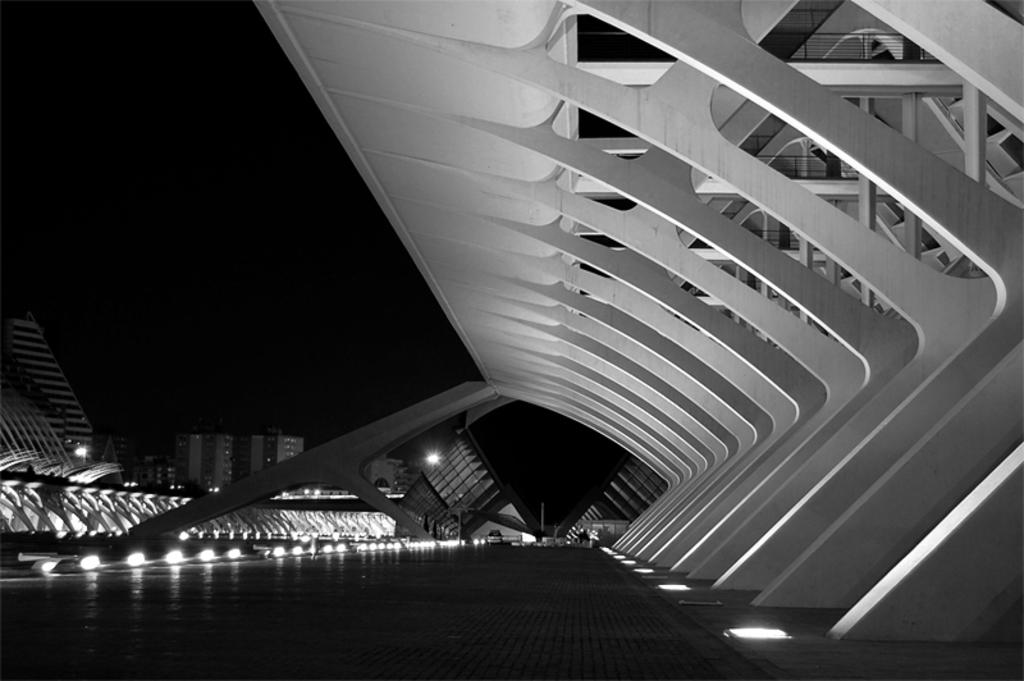What structure is located in the foreground of the image? There is a bridge in the foreground of the image. What other structure can be seen in the foreground of the image? There is an architecture in the foreground of the image. What type of structures are visible in the background of the image? There are buildings in the background of the image. What can be observed in the background of the image, besides the buildings? There is light visible in the background of the image. How does the man in the image test the bridge's ability to turn? There is no man present in the image, and the bridge is not depicted as turning. 